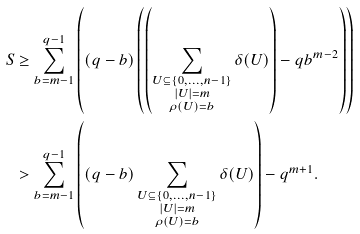Convert formula to latex. <formula><loc_0><loc_0><loc_500><loc_500>S & \geq \sum _ { b = m - 1 } ^ { q - 1 } { \left ( \left ( q - b \right ) \left ( \left ( \sum _ { \substack { U \subseteq \{ 0 , \dots , n - 1 \} \\ | U | = m \\ \rho ( U ) = b } } { \delta ( U ) } \right ) - q b ^ { m - 2 } \right ) \right ) } \\ & > \sum _ { b = m - 1 } ^ { q - 1 } { \left ( ( q - b ) \sum _ { \substack { U \subseteq \{ 0 , \dots , n - 1 \} \\ | U | = m \\ \rho ( U ) = b } } { \delta ( U ) } \right ) } - q ^ { m + 1 } . \\</formula> 